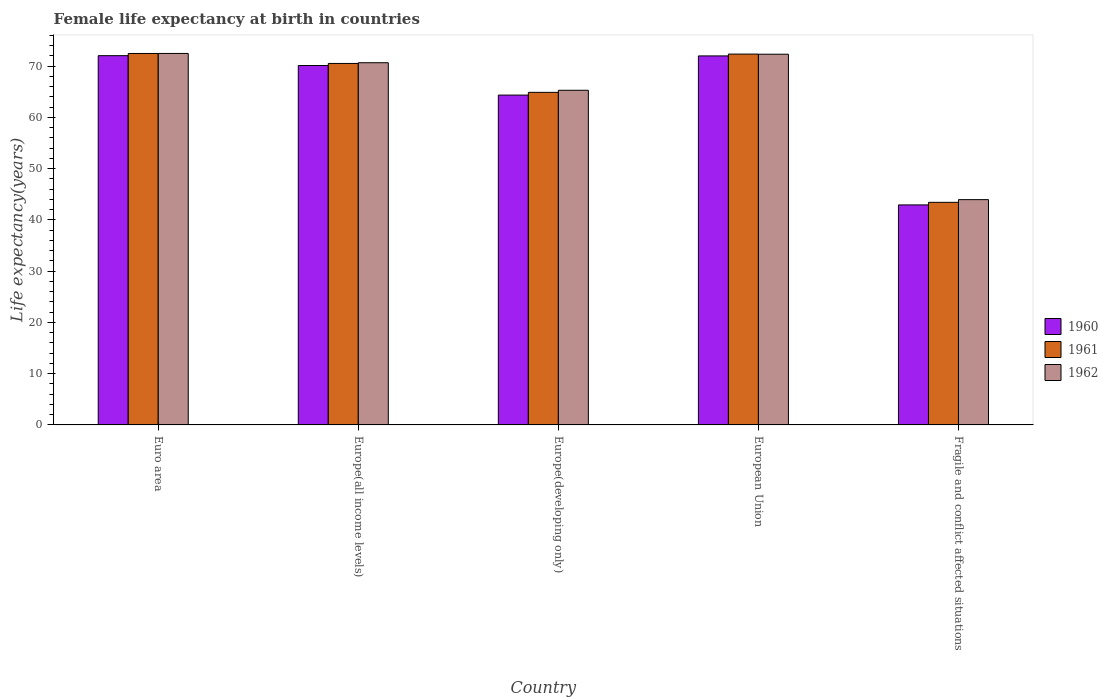How many groups of bars are there?
Make the answer very short. 5. How many bars are there on the 1st tick from the right?
Your answer should be compact. 3. What is the label of the 1st group of bars from the left?
Your response must be concise. Euro area. In how many cases, is the number of bars for a given country not equal to the number of legend labels?
Offer a terse response. 0. What is the female life expectancy at birth in 1960 in Europe(developing only)?
Your answer should be compact. 64.37. Across all countries, what is the maximum female life expectancy at birth in 1961?
Your response must be concise. 72.49. Across all countries, what is the minimum female life expectancy at birth in 1962?
Offer a very short reply. 43.97. In which country was the female life expectancy at birth in 1962 maximum?
Offer a very short reply. Euro area. In which country was the female life expectancy at birth in 1960 minimum?
Your response must be concise. Fragile and conflict affected situations. What is the total female life expectancy at birth in 1961 in the graph?
Provide a short and direct response. 323.76. What is the difference between the female life expectancy at birth in 1960 in European Union and that in Fragile and conflict affected situations?
Keep it short and to the point. 29.08. What is the difference between the female life expectancy at birth in 1960 in Europe(developing only) and the female life expectancy at birth in 1962 in Euro area?
Offer a terse response. -8.13. What is the average female life expectancy at birth in 1960 per country?
Provide a succinct answer. 64.31. What is the difference between the female life expectancy at birth of/in 1961 and female life expectancy at birth of/in 1962 in Euro area?
Offer a very short reply. -0.01. What is the ratio of the female life expectancy at birth in 1961 in Euro area to that in Europe(all income levels)?
Make the answer very short. 1.03. What is the difference between the highest and the second highest female life expectancy at birth in 1961?
Your answer should be very brief. 0.12. What is the difference between the highest and the lowest female life expectancy at birth in 1960?
Offer a terse response. 29.13. Is the sum of the female life expectancy at birth in 1961 in Europe(developing only) and Fragile and conflict affected situations greater than the maximum female life expectancy at birth in 1960 across all countries?
Offer a terse response. Yes. What does the 2nd bar from the left in Fragile and conflict affected situations represents?
Provide a short and direct response. 1961. Is it the case that in every country, the sum of the female life expectancy at birth in 1962 and female life expectancy at birth in 1961 is greater than the female life expectancy at birth in 1960?
Ensure brevity in your answer.  Yes. Are all the bars in the graph horizontal?
Your answer should be very brief. No. How many countries are there in the graph?
Keep it short and to the point. 5. What is the difference between two consecutive major ticks on the Y-axis?
Offer a very short reply. 10. How many legend labels are there?
Offer a terse response. 3. What is the title of the graph?
Your response must be concise. Female life expectancy at birth in countries. What is the label or title of the X-axis?
Offer a terse response. Country. What is the label or title of the Y-axis?
Provide a succinct answer. Life expectancy(years). What is the Life expectancy(years) in 1960 in Euro area?
Your response must be concise. 72.06. What is the Life expectancy(years) of 1961 in Euro area?
Provide a succinct answer. 72.49. What is the Life expectancy(years) of 1962 in Euro area?
Your answer should be compact. 72.5. What is the Life expectancy(years) in 1960 in Europe(all income levels)?
Offer a very short reply. 70.14. What is the Life expectancy(years) in 1961 in Europe(all income levels)?
Provide a short and direct response. 70.55. What is the Life expectancy(years) in 1962 in Europe(all income levels)?
Provide a succinct answer. 70.69. What is the Life expectancy(years) in 1960 in Europe(developing only)?
Your answer should be very brief. 64.37. What is the Life expectancy(years) in 1961 in Europe(developing only)?
Provide a succinct answer. 64.91. What is the Life expectancy(years) of 1962 in Europe(developing only)?
Offer a very short reply. 65.31. What is the Life expectancy(years) in 1960 in European Union?
Your answer should be very brief. 72.02. What is the Life expectancy(years) of 1961 in European Union?
Ensure brevity in your answer.  72.37. What is the Life expectancy(years) in 1962 in European Union?
Offer a terse response. 72.35. What is the Life expectancy(years) of 1960 in Fragile and conflict affected situations?
Offer a terse response. 42.94. What is the Life expectancy(years) in 1961 in Fragile and conflict affected situations?
Offer a very short reply. 43.44. What is the Life expectancy(years) of 1962 in Fragile and conflict affected situations?
Keep it short and to the point. 43.97. Across all countries, what is the maximum Life expectancy(years) in 1960?
Provide a succinct answer. 72.06. Across all countries, what is the maximum Life expectancy(years) in 1961?
Keep it short and to the point. 72.49. Across all countries, what is the maximum Life expectancy(years) in 1962?
Offer a very short reply. 72.5. Across all countries, what is the minimum Life expectancy(years) in 1960?
Provide a succinct answer. 42.94. Across all countries, what is the minimum Life expectancy(years) in 1961?
Offer a very short reply. 43.44. Across all countries, what is the minimum Life expectancy(years) in 1962?
Provide a short and direct response. 43.97. What is the total Life expectancy(years) in 1960 in the graph?
Give a very brief answer. 321.53. What is the total Life expectancy(years) in 1961 in the graph?
Your response must be concise. 323.76. What is the total Life expectancy(years) in 1962 in the graph?
Offer a very short reply. 324.81. What is the difference between the Life expectancy(years) of 1960 in Euro area and that in Europe(all income levels)?
Provide a succinct answer. 1.92. What is the difference between the Life expectancy(years) of 1961 in Euro area and that in Europe(all income levels)?
Ensure brevity in your answer.  1.94. What is the difference between the Life expectancy(years) in 1962 in Euro area and that in Europe(all income levels)?
Ensure brevity in your answer.  1.81. What is the difference between the Life expectancy(years) in 1960 in Euro area and that in Europe(developing only)?
Provide a short and direct response. 7.69. What is the difference between the Life expectancy(years) in 1961 in Euro area and that in Europe(developing only)?
Offer a terse response. 7.59. What is the difference between the Life expectancy(years) of 1962 in Euro area and that in Europe(developing only)?
Offer a terse response. 7.19. What is the difference between the Life expectancy(years) in 1960 in Euro area and that in European Union?
Give a very brief answer. 0.05. What is the difference between the Life expectancy(years) of 1961 in Euro area and that in European Union?
Keep it short and to the point. 0.12. What is the difference between the Life expectancy(years) in 1962 in Euro area and that in European Union?
Your answer should be compact. 0.15. What is the difference between the Life expectancy(years) of 1960 in Euro area and that in Fragile and conflict affected situations?
Your answer should be compact. 29.13. What is the difference between the Life expectancy(years) of 1961 in Euro area and that in Fragile and conflict affected situations?
Your response must be concise. 29.05. What is the difference between the Life expectancy(years) in 1962 in Euro area and that in Fragile and conflict affected situations?
Your response must be concise. 28.53. What is the difference between the Life expectancy(years) of 1960 in Europe(all income levels) and that in Europe(developing only)?
Give a very brief answer. 5.77. What is the difference between the Life expectancy(years) of 1961 in Europe(all income levels) and that in Europe(developing only)?
Your answer should be compact. 5.64. What is the difference between the Life expectancy(years) in 1962 in Europe(all income levels) and that in Europe(developing only)?
Provide a succinct answer. 5.38. What is the difference between the Life expectancy(years) of 1960 in Europe(all income levels) and that in European Union?
Ensure brevity in your answer.  -1.87. What is the difference between the Life expectancy(years) of 1961 in Europe(all income levels) and that in European Union?
Provide a short and direct response. -1.83. What is the difference between the Life expectancy(years) of 1962 in Europe(all income levels) and that in European Union?
Your answer should be compact. -1.66. What is the difference between the Life expectancy(years) of 1960 in Europe(all income levels) and that in Fragile and conflict affected situations?
Give a very brief answer. 27.2. What is the difference between the Life expectancy(years) in 1961 in Europe(all income levels) and that in Fragile and conflict affected situations?
Make the answer very short. 27.11. What is the difference between the Life expectancy(years) in 1962 in Europe(all income levels) and that in Fragile and conflict affected situations?
Provide a short and direct response. 26.72. What is the difference between the Life expectancy(years) of 1960 in Europe(developing only) and that in European Union?
Keep it short and to the point. -7.64. What is the difference between the Life expectancy(years) in 1961 in Europe(developing only) and that in European Union?
Offer a very short reply. -7.47. What is the difference between the Life expectancy(years) in 1962 in Europe(developing only) and that in European Union?
Offer a very short reply. -7.04. What is the difference between the Life expectancy(years) in 1960 in Europe(developing only) and that in Fragile and conflict affected situations?
Offer a terse response. 21.44. What is the difference between the Life expectancy(years) of 1961 in Europe(developing only) and that in Fragile and conflict affected situations?
Keep it short and to the point. 21.46. What is the difference between the Life expectancy(years) in 1962 in Europe(developing only) and that in Fragile and conflict affected situations?
Provide a succinct answer. 21.34. What is the difference between the Life expectancy(years) of 1960 in European Union and that in Fragile and conflict affected situations?
Provide a short and direct response. 29.08. What is the difference between the Life expectancy(years) of 1961 in European Union and that in Fragile and conflict affected situations?
Make the answer very short. 28.93. What is the difference between the Life expectancy(years) in 1962 in European Union and that in Fragile and conflict affected situations?
Offer a very short reply. 28.38. What is the difference between the Life expectancy(years) in 1960 in Euro area and the Life expectancy(years) in 1961 in Europe(all income levels)?
Give a very brief answer. 1.52. What is the difference between the Life expectancy(years) in 1960 in Euro area and the Life expectancy(years) in 1962 in Europe(all income levels)?
Give a very brief answer. 1.38. What is the difference between the Life expectancy(years) of 1961 in Euro area and the Life expectancy(years) of 1962 in Europe(all income levels)?
Provide a short and direct response. 1.8. What is the difference between the Life expectancy(years) in 1960 in Euro area and the Life expectancy(years) in 1961 in Europe(developing only)?
Give a very brief answer. 7.16. What is the difference between the Life expectancy(years) of 1960 in Euro area and the Life expectancy(years) of 1962 in Europe(developing only)?
Your response must be concise. 6.75. What is the difference between the Life expectancy(years) in 1961 in Euro area and the Life expectancy(years) in 1962 in Europe(developing only)?
Give a very brief answer. 7.18. What is the difference between the Life expectancy(years) of 1960 in Euro area and the Life expectancy(years) of 1961 in European Union?
Give a very brief answer. -0.31. What is the difference between the Life expectancy(years) of 1960 in Euro area and the Life expectancy(years) of 1962 in European Union?
Ensure brevity in your answer.  -0.28. What is the difference between the Life expectancy(years) of 1961 in Euro area and the Life expectancy(years) of 1962 in European Union?
Your response must be concise. 0.14. What is the difference between the Life expectancy(years) of 1960 in Euro area and the Life expectancy(years) of 1961 in Fragile and conflict affected situations?
Make the answer very short. 28.62. What is the difference between the Life expectancy(years) of 1960 in Euro area and the Life expectancy(years) of 1962 in Fragile and conflict affected situations?
Keep it short and to the point. 28.1. What is the difference between the Life expectancy(years) in 1961 in Euro area and the Life expectancy(years) in 1962 in Fragile and conflict affected situations?
Ensure brevity in your answer.  28.52. What is the difference between the Life expectancy(years) in 1960 in Europe(all income levels) and the Life expectancy(years) in 1961 in Europe(developing only)?
Make the answer very short. 5.24. What is the difference between the Life expectancy(years) in 1960 in Europe(all income levels) and the Life expectancy(years) in 1962 in Europe(developing only)?
Your answer should be very brief. 4.83. What is the difference between the Life expectancy(years) of 1961 in Europe(all income levels) and the Life expectancy(years) of 1962 in Europe(developing only)?
Offer a terse response. 5.24. What is the difference between the Life expectancy(years) in 1960 in Europe(all income levels) and the Life expectancy(years) in 1961 in European Union?
Your response must be concise. -2.23. What is the difference between the Life expectancy(years) of 1960 in Europe(all income levels) and the Life expectancy(years) of 1962 in European Union?
Ensure brevity in your answer.  -2.21. What is the difference between the Life expectancy(years) in 1961 in Europe(all income levels) and the Life expectancy(years) in 1962 in European Union?
Offer a very short reply. -1.8. What is the difference between the Life expectancy(years) of 1960 in Europe(all income levels) and the Life expectancy(years) of 1961 in Fragile and conflict affected situations?
Give a very brief answer. 26.7. What is the difference between the Life expectancy(years) of 1960 in Europe(all income levels) and the Life expectancy(years) of 1962 in Fragile and conflict affected situations?
Offer a very short reply. 26.17. What is the difference between the Life expectancy(years) of 1961 in Europe(all income levels) and the Life expectancy(years) of 1962 in Fragile and conflict affected situations?
Keep it short and to the point. 26.58. What is the difference between the Life expectancy(years) of 1960 in Europe(developing only) and the Life expectancy(years) of 1961 in European Union?
Your answer should be compact. -8. What is the difference between the Life expectancy(years) in 1960 in Europe(developing only) and the Life expectancy(years) in 1962 in European Union?
Provide a short and direct response. -7.98. What is the difference between the Life expectancy(years) in 1961 in Europe(developing only) and the Life expectancy(years) in 1962 in European Union?
Provide a short and direct response. -7.44. What is the difference between the Life expectancy(years) in 1960 in Europe(developing only) and the Life expectancy(years) in 1961 in Fragile and conflict affected situations?
Your answer should be compact. 20.93. What is the difference between the Life expectancy(years) of 1960 in Europe(developing only) and the Life expectancy(years) of 1962 in Fragile and conflict affected situations?
Your response must be concise. 20.4. What is the difference between the Life expectancy(years) of 1961 in Europe(developing only) and the Life expectancy(years) of 1962 in Fragile and conflict affected situations?
Provide a short and direct response. 20.94. What is the difference between the Life expectancy(years) in 1960 in European Union and the Life expectancy(years) in 1961 in Fragile and conflict affected situations?
Keep it short and to the point. 28.57. What is the difference between the Life expectancy(years) in 1960 in European Union and the Life expectancy(years) in 1962 in Fragile and conflict affected situations?
Your response must be concise. 28.05. What is the difference between the Life expectancy(years) in 1961 in European Union and the Life expectancy(years) in 1962 in Fragile and conflict affected situations?
Keep it short and to the point. 28.41. What is the average Life expectancy(years) of 1960 per country?
Your response must be concise. 64.31. What is the average Life expectancy(years) of 1961 per country?
Offer a very short reply. 64.75. What is the average Life expectancy(years) in 1962 per country?
Your response must be concise. 64.96. What is the difference between the Life expectancy(years) of 1960 and Life expectancy(years) of 1961 in Euro area?
Provide a short and direct response. -0.43. What is the difference between the Life expectancy(years) in 1960 and Life expectancy(years) in 1962 in Euro area?
Your response must be concise. -0.43. What is the difference between the Life expectancy(years) in 1961 and Life expectancy(years) in 1962 in Euro area?
Your answer should be very brief. -0.01. What is the difference between the Life expectancy(years) of 1960 and Life expectancy(years) of 1961 in Europe(all income levels)?
Your response must be concise. -0.41. What is the difference between the Life expectancy(years) in 1960 and Life expectancy(years) in 1962 in Europe(all income levels)?
Your answer should be very brief. -0.55. What is the difference between the Life expectancy(years) of 1961 and Life expectancy(years) of 1962 in Europe(all income levels)?
Your response must be concise. -0.14. What is the difference between the Life expectancy(years) of 1960 and Life expectancy(years) of 1961 in Europe(developing only)?
Offer a terse response. -0.53. What is the difference between the Life expectancy(years) of 1960 and Life expectancy(years) of 1962 in Europe(developing only)?
Give a very brief answer. -0.94. What is the difference between the Life expectancy(years) in 1961 and Life expectancy(years) in 1962 in Europe(developing only)?
Offer a terse response. -0.41. What is the difference between the Life expectancy(years) in 1960 and Life expectancy(years) in 1961 in European Union?
Give a very brief answer. -0.36. What is the difference between the Life expectancy(years) in 1960 and Life expectancy(years) in 1962 in European Union?
Your response must be concise. -0.33. What is the difference between the Life expectancy(years) in 1961 and Life expectancy(years) in 1962 in European Union?
Keep it short and to the point. 0.03. What is the difference between the Life expectancy(years) in 1960 and Life expectancy(years) in 1961 in Fragile and conflict affected situations?
Ensure brevity in your answer.  -0.5. What is the difference between the Life expectancy(years) in 1960 and Life expectancy(years) in 1962 in Fragile and conflict affected situations?
Your response must be concise. -1.03. What is the difference between the Life expectancy(years) of 1961 and Life expectancy(years) of 1962 in Fragile and conflict affected situations?
Make the answer very short. -0.53. What is the ratio of the Life expectancy(years) in 1960 in Euro area to that in Europe(all income levels)?
Ensure brevity in your answer.  1.03. What is the ratio of the Life expectancy(years) of 1961 in Euro area to that in Europe(all income levels)?
Provide a short and direct response. 1.03. What is the ratio of the Life expectancy(years) of 1962 in Euro area to that in Europe(all income levels)?
Provide a succinct answer. 1.03. What is the ratio of the Life expectancy(years) of 1960 in Euro area to that in Europe(developing only)?
Give a very brief answer. 1.12. What is the ratio of the Life expectancy(years) in 1961 in Euro area to that in Europe(developing only)?
Give a very brief answer. 1.12. What is the ratio of the Life expectancy(years) in 1962 in Euro area to that in Europe(developing only)?
Give a very brief answer. 1.11. What is the ratio of the Life expectancy(years) of 1961 in Euro area to that in European Union?
Your response must be concise. 1. What is the ratio of the Life expectancy(years) in 1960 in Euro area to that in Fragile and conflict affected situations?
Your answer should be very brief. 1.68. What is the ratio of the Life expectancy(years) of 1961 in Euro area to that in Fragile and conflict affected situations?
Give a very brief answer. 1.67. What is the ratio of the Life expectancy(years) in 1962 in Euro area to that in Fragile and conflict affected situations?
Offer a very short reply. 1.65. What is the ratio of the Life expectancy(years) in 1960 in Europe(all income levels) to that in Europe(developing only)?
Offer a terse response. 1.09. What is the ratio of the Life expectancy(years) of 1961 in Europe(all income levels) to that in Europe(developing only)?
Your answer should be compact. 1.09. What is the ratio of the Life expectancy(years) in 1962 in Europe(all income levels) to that in Europe(developing only)?
Keep it short and to the point. 1.08. What is the ratio of the Life expectancy(years) in 1960 in Europe(all income levels) to that in European Union?
Give a very brief answer. 0.97. What is the ratio of the Life expectancy(years) in 1961 in Europe(all income levels) to that in European Union?
Your response must be concise. 0.97. What is the ratio of the Life expectancy(years) in 1962 in Europe(all income levels) to that in European Union?
Your response must be concise. 0.98. What is the ratio of the Life expectancy(years) of 1960 in Europe(all income levels) to that in Fragile and conflict affected situations?
Give a very brief answer. 1.63. What is the ratio of the Life expectancy(years) in 1961 in Europe(all income levels) to that in Fragile and conflict affected situations?
Keep it short and to the point. 1.62. What is the ratio of the Life expectancy(years) of 1962 in Europe(all income levels) to that in Fragile and conflict affected situations?
Your response must be concise. 1.61. What is the ratio of the Life expectancy(years) in 1960 in Europe(developing only) to that in European Union?
Provide a short and direct response. 0.89. What is the ratio of the Life expectancy(years) of 1961 in Europe(developing only) to that in European Union?
Your answer should be compact. 0.9. What is the ratio of the Life expectancy(years) of 1962 in Europe(developing only) to that in European Union?
Your response must be concise. 0.9. What is the ratio of the Life expectancy(years) of 1960 in Europe(developing only) to that in Fragile and conflict affected situations?
Provide a short and direct response. 1.5. What is the ratio of the Life expectancy(years) in 1961 in Europe(developing only) to that in Fragile and conflict affected situations?
Provide a succinct answer. 1.49. What is the ratio of the Life expectancy(years) in 1962 in Europe(developing only) to that in Fragile and conflict affected situations?
Your response must be concise. 1.49. What is the ratio of the Life expectancy(years) in 1960 in European Union to that in Fragile and conflict affected situations?
Offer a very short reply. 1.68. What is the ratio of the Life expectancy(years) in 1961 in European Union to that in Fragile and conflict affected situations?
Offer a terse response. 1.67. What is the ratio of the Life expectancy(years) of 1962 in European Union to that in Fragile and conflict affected situations?
Your answer should be very brief. 1.65. What is the difference between the highest and the second highest Life expectancy(years) in 1960?
Offer a terse response. 0.05. What is the difference between the highest and the second highest Life expectancy(years) in 1961?
Provide a short and direct response. 0.12. What is the difference between the highest and the second highest Life expectancy(years) in 1962?
Provide a short and direct response. 0.15. What is the difference between the highest and the lowest Life expectancy(years) of 1960?
Your answer should be compact. 29.13. What is the difference between the highest and the lowest Life expectancy(years) in 1961?
Ensure brevity in your answer.  29.05. What is the difference between the highest and the lowest Life expectancy(years) in 1962?
Ensure brevity in your answer.  28.53. 